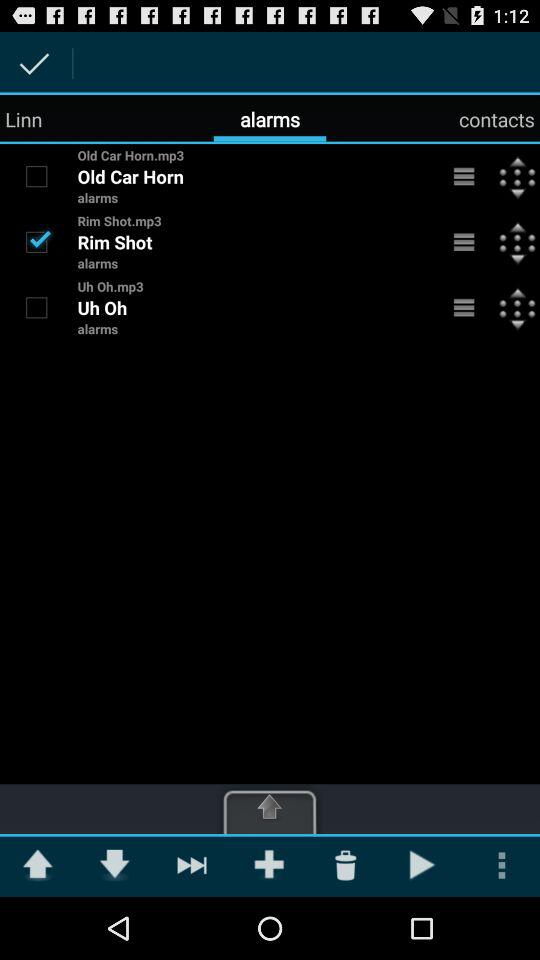How many alarms are there?
Answer the question using a single word or phrase. 3 